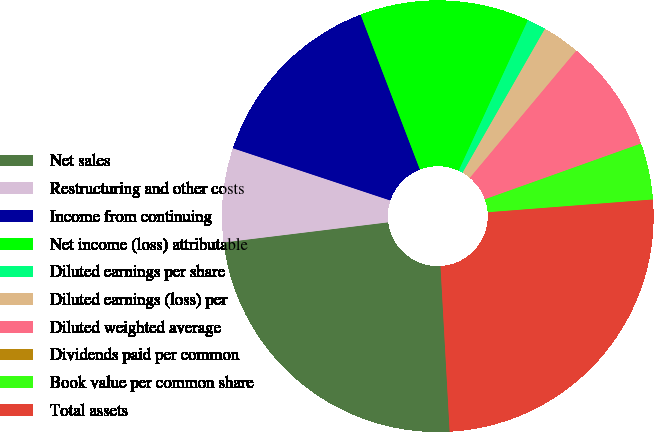<chart> <loc_0><loc_0><loc_500><loc_500><pie_chart><fcel>Net sales<fcel>Restructuring and other costs<fcel>Income from continuing<fcel>Net income (loss) attributable<fcel>Diluted earnings per share<fcel>Diluted earnings (loss) per<fcel>Diluted weighted average<fcel>Dividends paid per common<fcel>Book value per common share<fcel>Total assets<nl><fcel>23.94%<fcel>7.04%<fcel>14.08%<fcel>12.68%<fcel>1.41%<fcel>2.82%<fcel>8.45%<fcel>0.0%<fcel>4.23%<fcel>25.35%<nl></chart> 